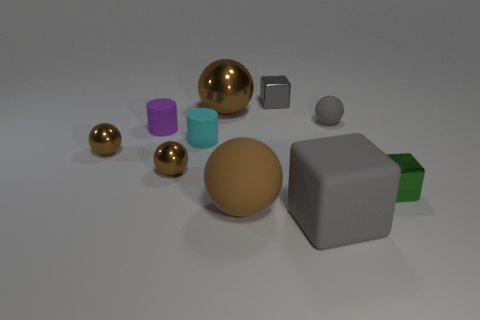Subtract all small brown spheres. How many spheres are left? 3 Subtract all cubes. How many objects are left? 7 Subtract all gray cubes. How many cubes are left? 1 Subtract 2 cylinders. How many cylinders are left? 0 Subtract all yellow cubes. Subtract all green balls. How many cubes are left? 3 Subtract all green cubes. How many gray spheres are left? 1 Subtract all brown rubber things. Subtract all tiny shiny things. How many objects are left? 5 Add 6 matte cylinders. How many matte cylinders are left? 8 Add 4 big rubber cubes. How many big rubber cubes exist? 5 Subtract 0 brown cylinders. How many objects are left? 10 